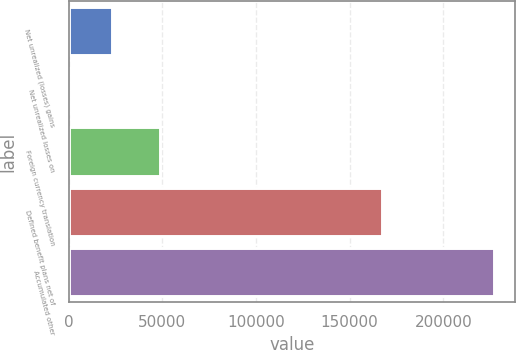Convert chart to OTSL. <chart><loc_0><loc_0><loc_500><loc_500><bar_chart><fcel>Net unrealized (losses) gains<fcel>Net unrealized losses on<fcel>Foreign currency translation<fcel>Defined benefit plans net of<fcel>Accumulated other<nl><fcel>22939.2<fcel>246<fcel>48899<fcel>167458<fcel>227178<nl></chart> 